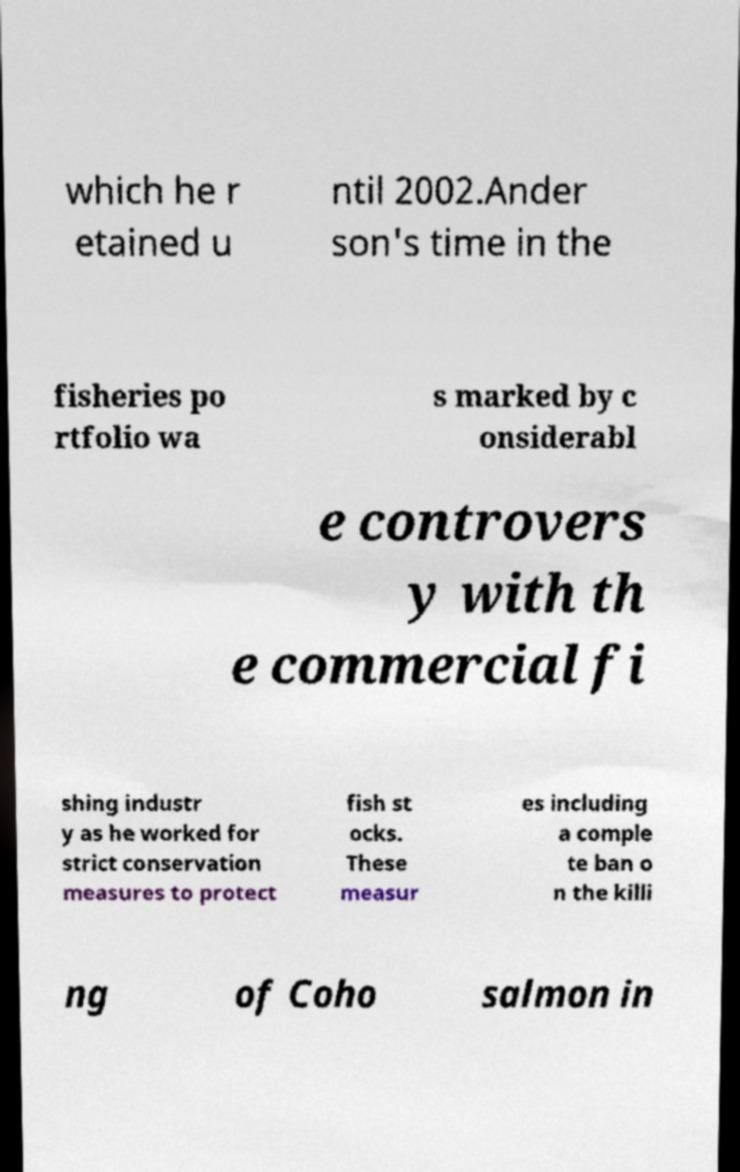For documentation purposes, I need the text within this image transcribed. Could you provide that? which he r etained u ntil 2002.Ander son's time in the fisheries po rtfolio wa s marked by c onsiderabl e controvers y with th e commercial fi shing industr y as he worked for strict conservation measures to protect fish st ocks. These measur es including a comple te ban o n the killi ng of Coho salmon in 